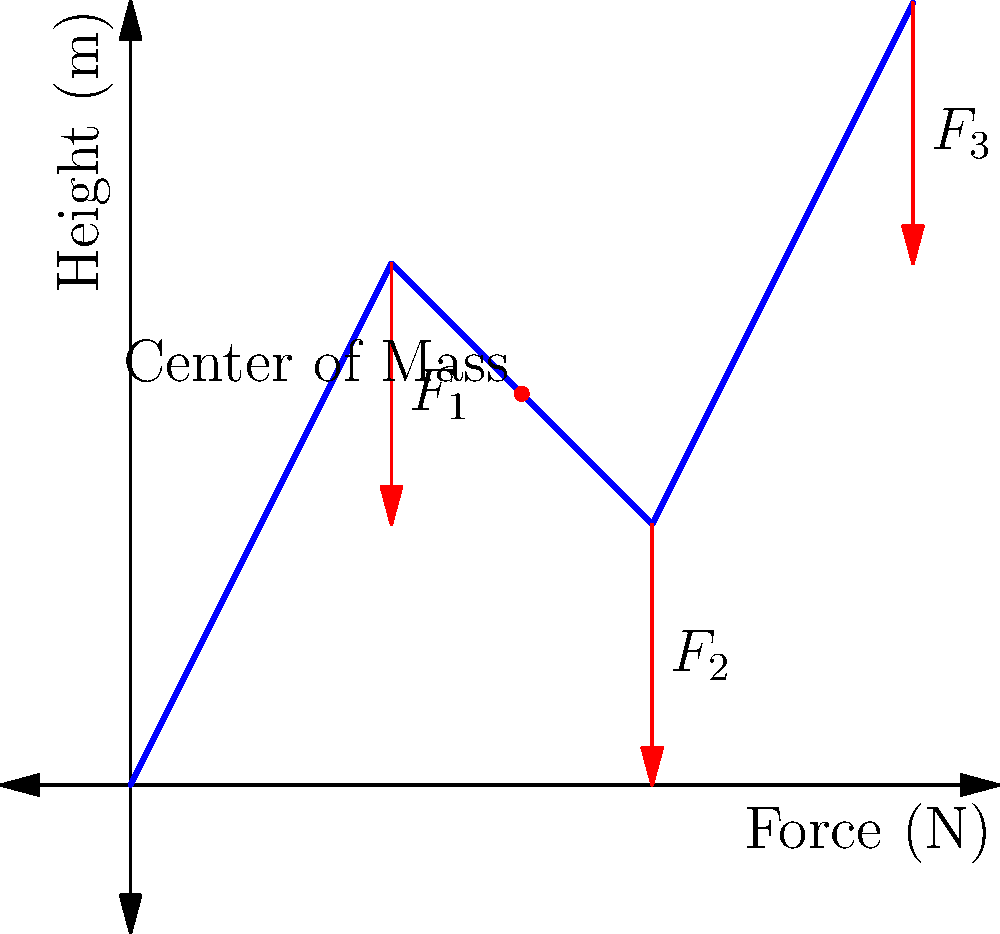A large-scale kinetic art installation is subject to three downward forces $F_1$, $F_2$, and $F_3$ as shown in the diagram. If the installation weighs 1000 kg and is in equilibrium, what is the magnitude of $F_2$ in Newtons, given that $F_1 = 2000$ N and $F_3 = 3000$ N? To solve this problem, we'll follow these steps:

1. Recognize that for the installation to be in equilibrium, the sum of all forces must equal zero.

2. Calculate the total downward force due to gravity:
   $F_g = mg = 1000 \text{ kg} \times 9.8 \text{ m/s}^2 = 9800 \text{ N}$

3. Set up the equation for equilibrium:
   $F_1 + F_2 + F_3 = F_g$

4. Substitute the known values:
   $2000 \text{ N} + F_2 + 3000 \text{ N} = 9800 \text{ N}$

5. Solve for $F_2$:
   $F_2 = 9800 \text{ N} - 2000 \text{ N} - 3000 \text{ N} = 4800 \text{ N}$

Therefore, the magnitude of $F_2$ is 4800 N.
Answer: 4800 N 